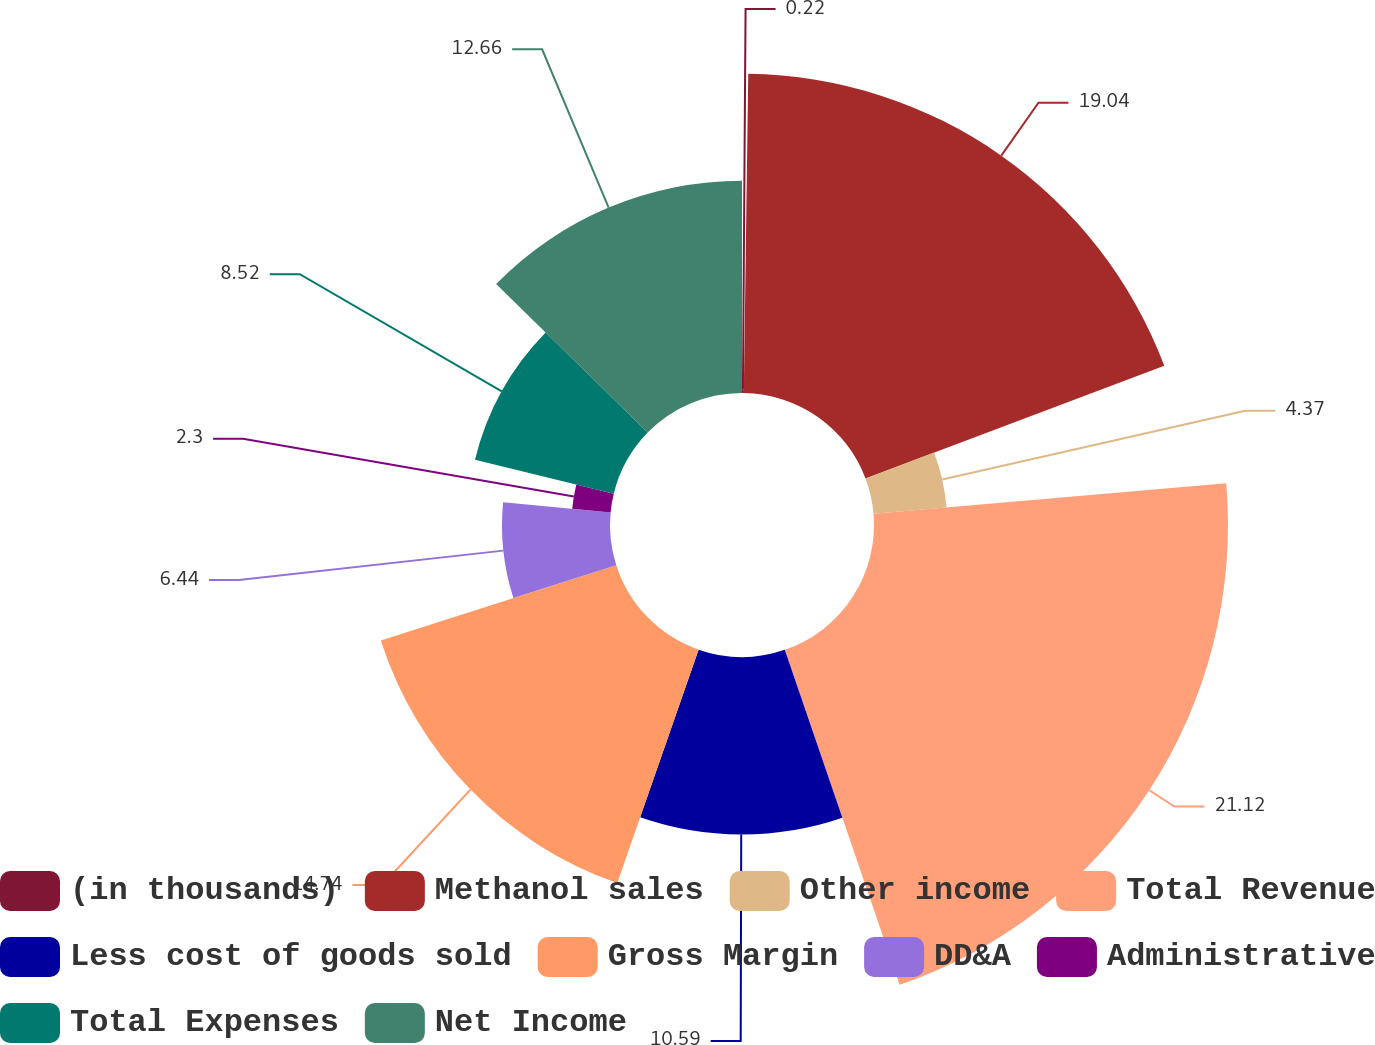Convert chart. <chart><loc_0><loc_0><loc_500><loc_500><pie_chart><fcel>(in thousands)<fcel>Methanol sales<fcel>Other income<fcel>Total Revenue<fcel>Less cost of goods sold<fcel>Gross Margin<fcel>DD&A<fcel>Administrative<fcel>Total Expenses<fcel>Net Income<nl><fcel>0.22%<fcel>19.04%<fcel>4.37%<fcel>21.11%<fcel>10.59%<fcel>14.74%<fcel>6.44%<fcel>2.3%<fcel>8.52%<fcel>12.66%<nl></chart> 